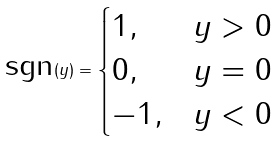Convert formula to latex. <formula><loc_0><loc_0><loc_500><loc_500>\text {sgn} ( y ) = \begin{cases} 1 , & y > 0 \\ 0 , & y = 0 \\ - 1 , & y < 0 \end{cases}</formula> 